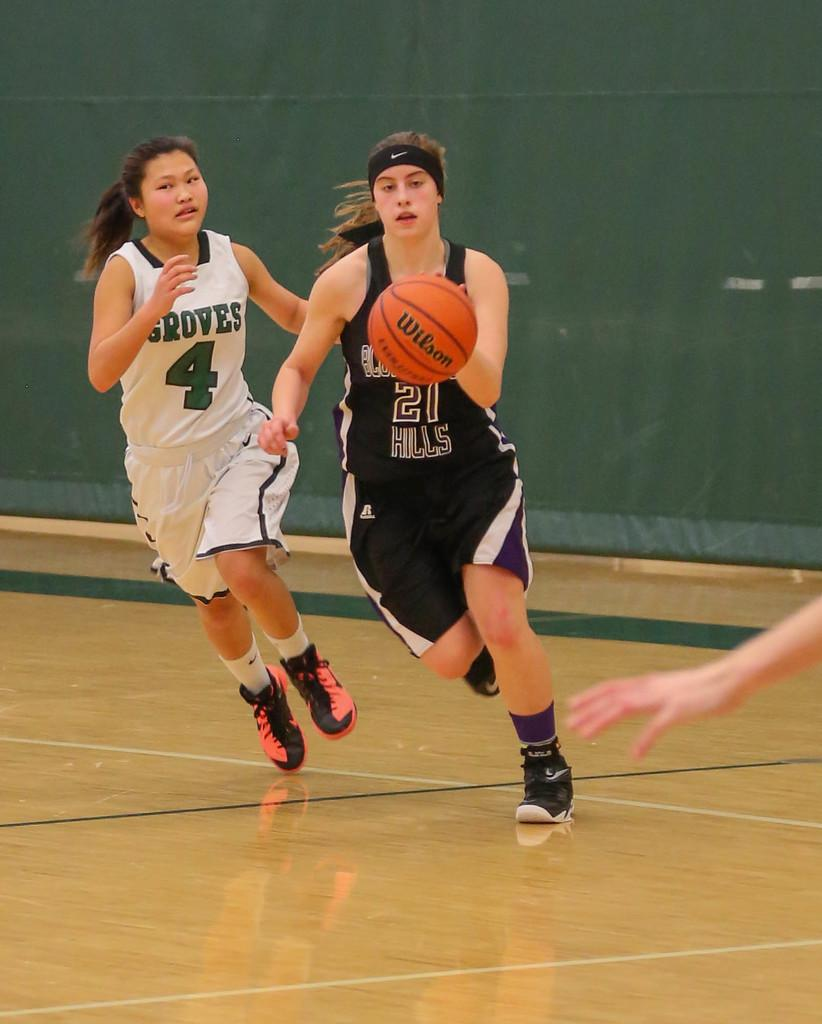<image>
Give a short and clear explanation of the subsequent image. Two basketball players, one from Groves and one from Hills. 